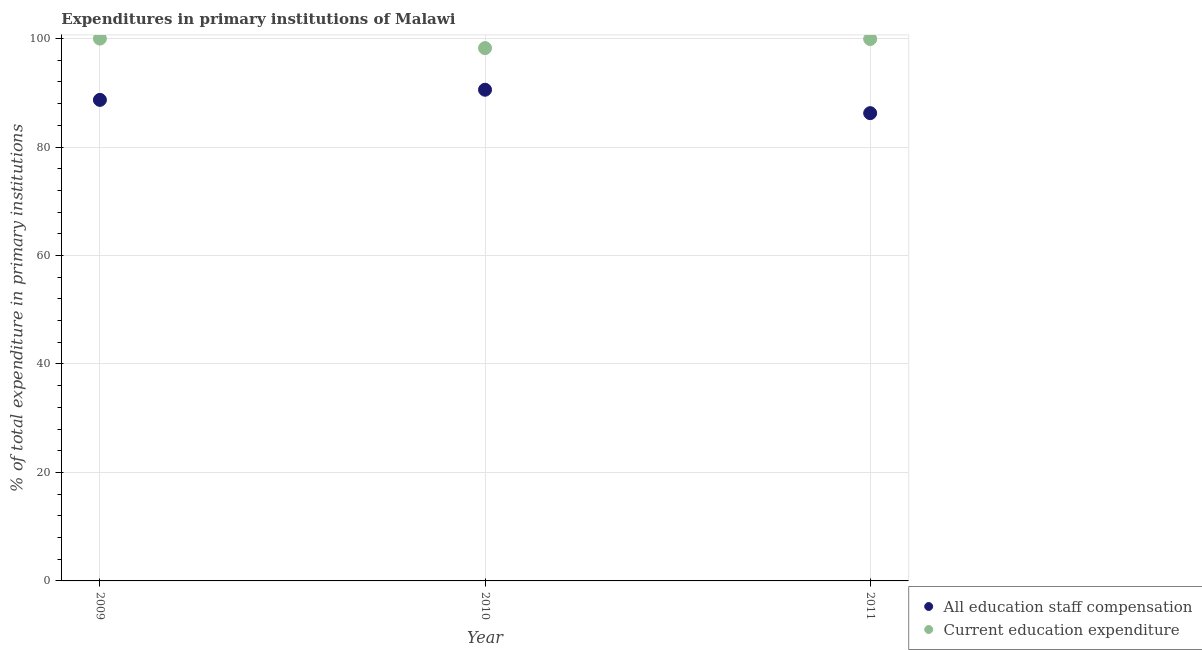What is the expenditure in staff compensation in 2010?
Ensure brevity in your answer.  90.57. Across all years, what is the maximum expenditure in staff compensation?
Make the answer very short. 90.57. Across all years, what is the minimum expenditure in staff compensation?
Keep it short and to the point. 86.25. In which year was the expenditure in staff compensation maximum?
Your response must be concise. 2010. In which year was the expenditure in education minimum?
Your answer should be compact. 2010. What is the total expenditure in education in the graph?
Offer a very short reply. 298.17. What is the difference between the expenditure in staff compensation in 2009 and that in 2011?
Provide a succinct answer. 2.45. What is the difference between the expenditure in staff compensation in 2011 and the expenditure in education in 2010?
Provide a succinct answer. -12. What is the average expenditure in education per year?
Provide a short and direct response. 99.39. In the year 2009, what is the difference between the expenditure in staff compensation and expenditure in education?
Provide a succinct answer. -11.3. What is the ratio of the expenditure in education in 2009 to that in 2011?
Offer a very short reply. 1. Is the difference between the expenditure in education in 2009 and 2010 greater than the difference between the expenditure in staff compensation in 2009 and 2010?
Keep it short and to the point. Yes. What is the difference between the highest and the second highest expenditure in staff compensation?
Provide a succinct answer. 1.87. What is the difference between the highest and the lowest expenditure in staff compensation?
Give a very brief answer. 4.32. Does the expenditure in education monotonically increase over the years?
Offer a very short reply. No. Is the expenditure in staff compensation strictly less than the expenditure in education over the years?
Provide a succinct answer. Yes. How many dotlines are there?
Your response must be concise. 2. Does the graph contain any zero values?
Your answer should be compact. No. What is the title of the graph?
Make the answer very short. Expenditures in primary institutions of Malawi. Does "Forest land" appear as one of the legend labels in the graph?
Ensure brevity in your answer.  No. What is the label or title of the X-axis?
Make the answer very short. Year. What is the label or title of the Y-axis?
Provide a succinct answer. % of total expenditure in primary institutions. What is the % of total expenditure in primary institutions of All education staff compensation in 2009?
Make the answer very short. 88.7. What is the % of total expenditure in primary institutions of All education staff compensation in 2010?
Offer a terse response. 90.57. What is the % of total expenditure in primary institutions of Current education expenditure in 2010?
Your answer should be compact. 98.25. What is the % of total expenditure in primary institutions of All education staff compensation in 2011?
Your answer should be compact. 86.25. What is the % of total expenditure in primary institutions of Current education expenditure in 2011?
Give a very brief answer. 99.93. Across all years, what is the maximum % of total expenditure in primary institutions of All education staff compensation?
Provide a short and direct response. 90.57. Across all years, what is the minimum % of total expenditure in primary institutions of All education staff compensation?
Offer a very short reply. 86.25. Across all years, what is the minimum % of total expenditure in primary institutions of Current education expenditure?
Your response must be concise. 98.25. What is the total % of total expenditure in primary institutions in All education staff compensation in the graph?
Ensure brevity in your answer.  265.53. What is the total % of total expenditure in primary institutions of Current education expenditure in the graph?
Make the answer very short. 298.17. What is the difference between the % of total expenditure in primary institutions of All education staff compensation in 2009 and that in 2010?
Your response must be concise. -1.87. What is the difference between the % of total expenditure in primary institutions of Current education expenditure in 2009 and that in 2010?
Your response must be concise. 1.75. What is the difference between the % of total expenditure in primary institutions in All education staff compensation in 2009 and that in 2011?
Your answer should be compact. 2.45. What is the difference between the % of total expenditure in primary institutions in Current education expenditure in 2009 and that in 2011?
Offer a very short reply. 0.07. What is the difference between the % of total expenditure in primary institutions of All education staff compensation in 2010 and that in 2011?
Provide a short and direct response. 4.32. What is the difference between the % of total expenditure in primary institutions of Current education expenditure in 2010 and that in 2011?
Your answer should be very brief. -1.68. What is the difference between the % of total expenditure in primary institutions of All education staff compensation in 2009 and the % of total expenditure in primary institutions of Current education expenditure in 2010?
Keep it short and to the point. -9.55. What is the difference between the % of total expenditure in primary institutions of All education staff compensation in 2009 and the % of total expenditure in primary institutions of Current education expenditure in 2011?
Give a very brief answer. -11.23. What is the difference between the % of total expenditure in primary institutions of All education staff compensation in 2010 and the % of total expenditure in primary institutions of Current education expenditure in 2011?
Your answer should be compact. -9.35. What is the average % of total expenditure in primary institutions in All education staff compensation per year?
Offer a terse response. 88.51. What is the average % of total expenditure in primary institutions of Current education expenditure per year?
Provide a short and direct response. 99.39. In the year 2009, what is the difference between the % of total expenditure in primary institutions of All education staff compensation and % of total expenditure in primary institutions of Current education expenditure?
Offer a terse response. -11.3. In the year 2010, what is the difference between the % of total expenditure in primary institutions in All education staff compensation and % of total expenditure in primary institutions in Current education expenditure?
Offer a terse response. -7.68. In the year 2011, what is the difference between the % of total expenditure in primary institutions in All education staff compensation and % of total expenditure in primary institutions in Current education expenditure?
Offer a very short reply. -13.67. What is the ratio of the % of total expenditure in primary institutions of All education staff compensation in 2009 to that in 2010?
Give a very brief answer. 0.98. What is the ratio of the % of total expenditure in primary institutions in Current education expenditure in 2009 to that in 2010?
Offer a very short reply. 1.02. What is the ratio of the % of total expenditure in primary institutions in All education staff compensation in 2009 to that in 2011?
Provide a short and direct response. 1.03. What is the ratio of the % of total expenditure in primary institutions of Current education expenditure in 2009 to that in 2011?
Ensure brevity in your answer.  1. What is the ratio of the % of total expenditure in primary institutions of All education staff compensation in 2010 to that in 2011?
Keep it short and to the point. 1.05. What is the ratio of the % of total expenditure in primary institutions in Current education expenditure in 2010 to that in 2011?
Your answer should be very brief. 0.98. What is the difference between the highest and the second highest % of total expenditure in primary institutions in All education staff compensation?
Your response must be concise. 1.87. What is the difference between the highest and the second highest % of total expenditure in primary institutions in Current education expenditure?
Offer a very short reply. 0.07. What is the difference between the highest and the lowest % of total expenditure in primary institutions in All education staff compensation?
Keep it short and to the point. 4.32. What is the difference between the highest and the lowest % of total expenditure in primary institutions in Current education expenditure?
Keep it short and to the point. 1.75. 